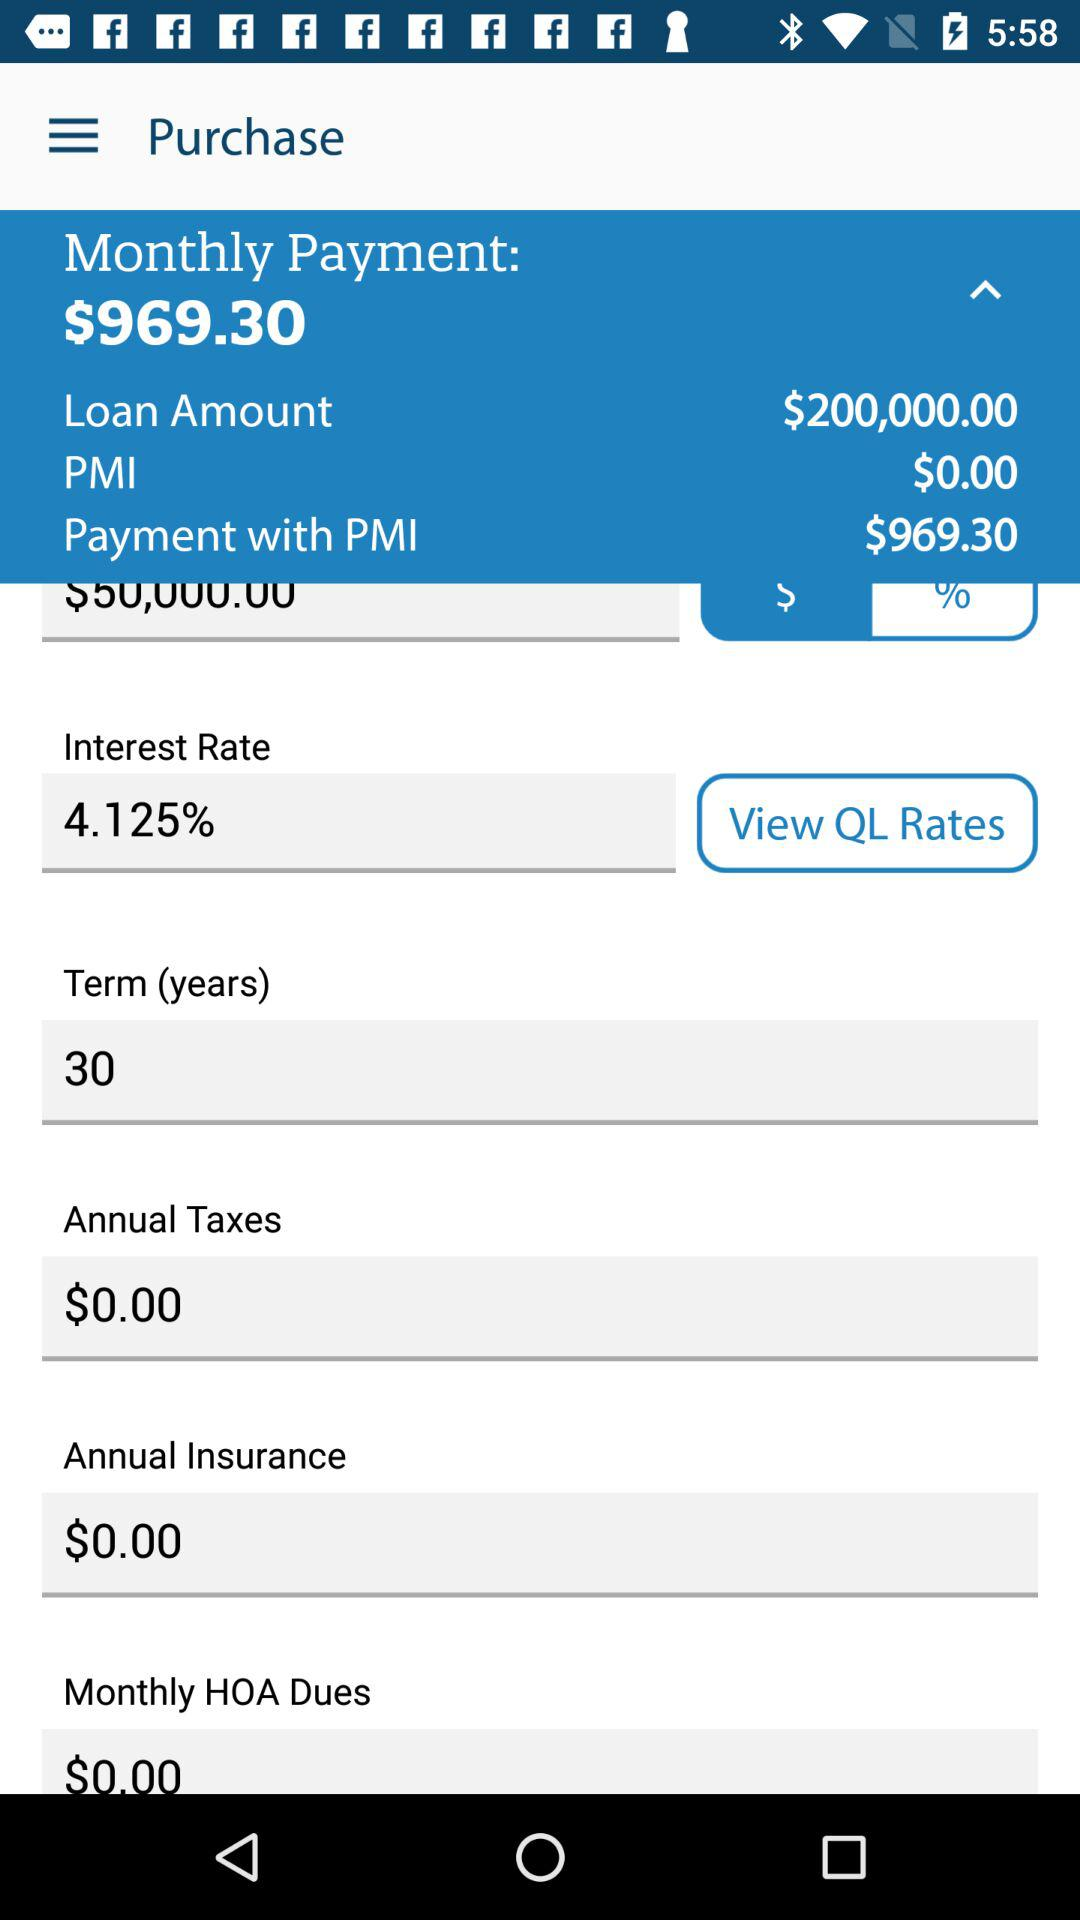How much is the annual tax? The annual tax is $0. 